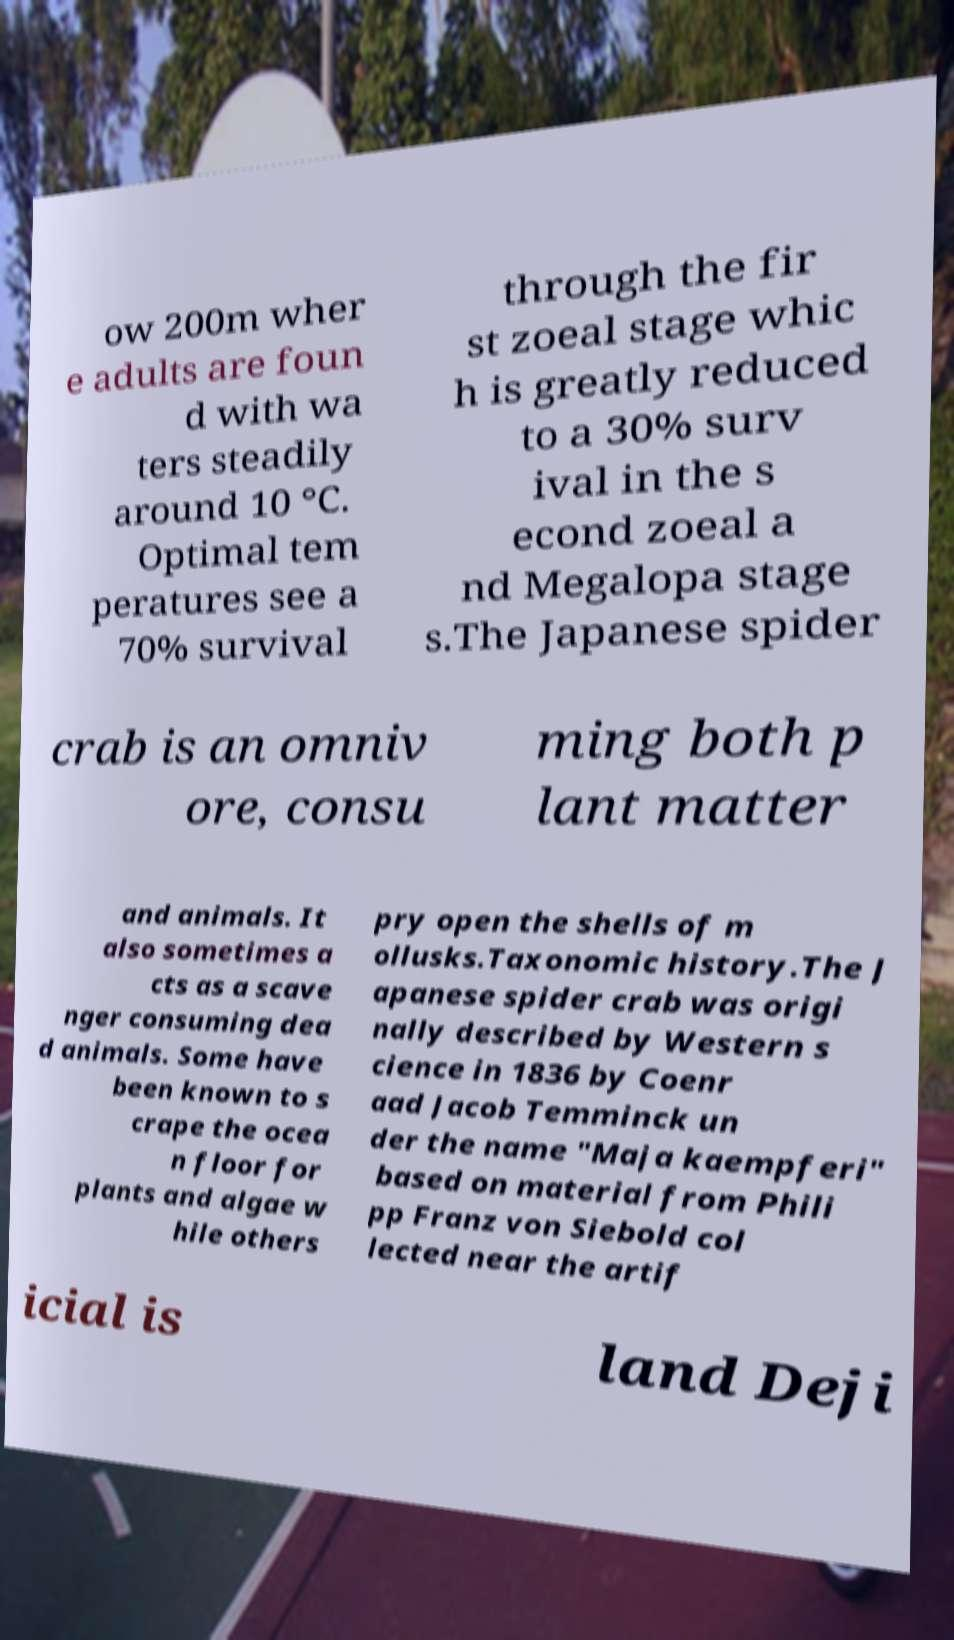Can you accurately transcribe the text from the provided image for me? ow 200m wher e adults are foun d with wa ters steadily around 10 °C. Optimal tem peratures see a 70% survival through the fir st zoeal stage whic h is greatly reduced to a 30% surv ival in the s econd zoeal a nd Megalopa stage s.The Japanese spider crab is an omniv ore, consu ming both p lant matter and animals. It also sometimes a cts as a scave nger consuming dea d animals. Some have been known to s crape the ocea n floor for plants and algae w hile others pry open the shells of m ollusks.Taxonomic history.The J apanese spider crab was origi nally described by Western s cience in 1836 by Coenr aad Jacob Temminck un der the name "Maja kaempferi" based on material from Phili pp Franz von Siebold col lected near the artif icial is land Deji 